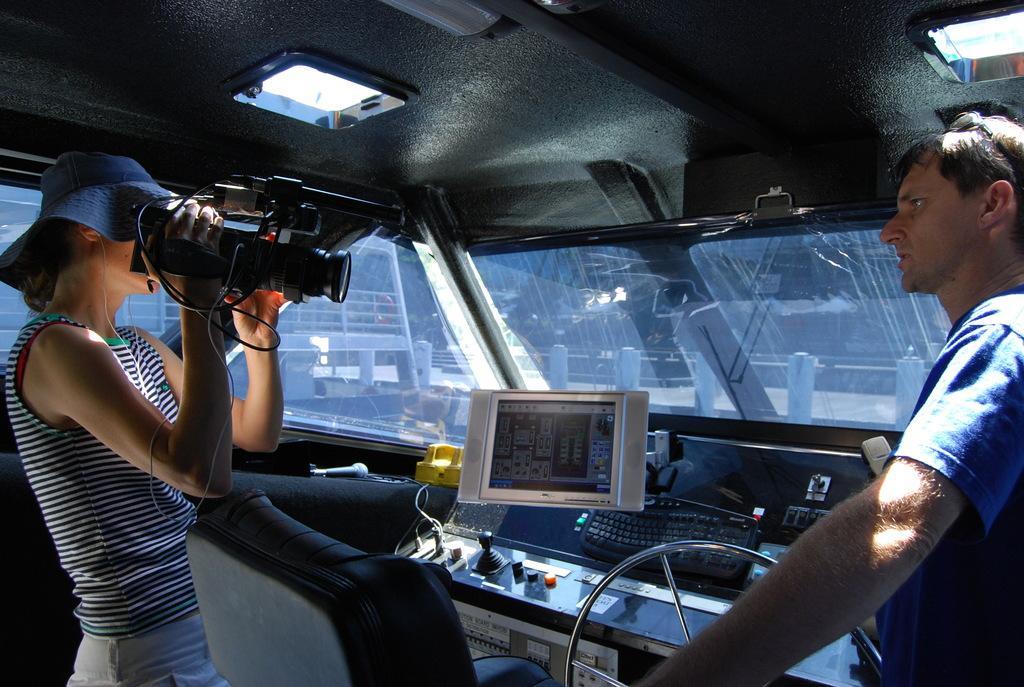Could you give a brief overview of what you see in this image? In this image, there are a few people. Among them, we can see a person holding some object. We can also see the chair and the glass wall. We can see some devices and a screen. We can also see a keyboard. We can see the view from the glass wall. We can see the fence and the roof with some objects attached to it. 